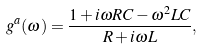<formula> <loc_0><loc_0><loc_500><loc_500>g ^ { a } ( \omega ) = \frac { 1 + i \omega R C - \omega ^ { 2 } L C } { R + i \omega L } ,</formula> 